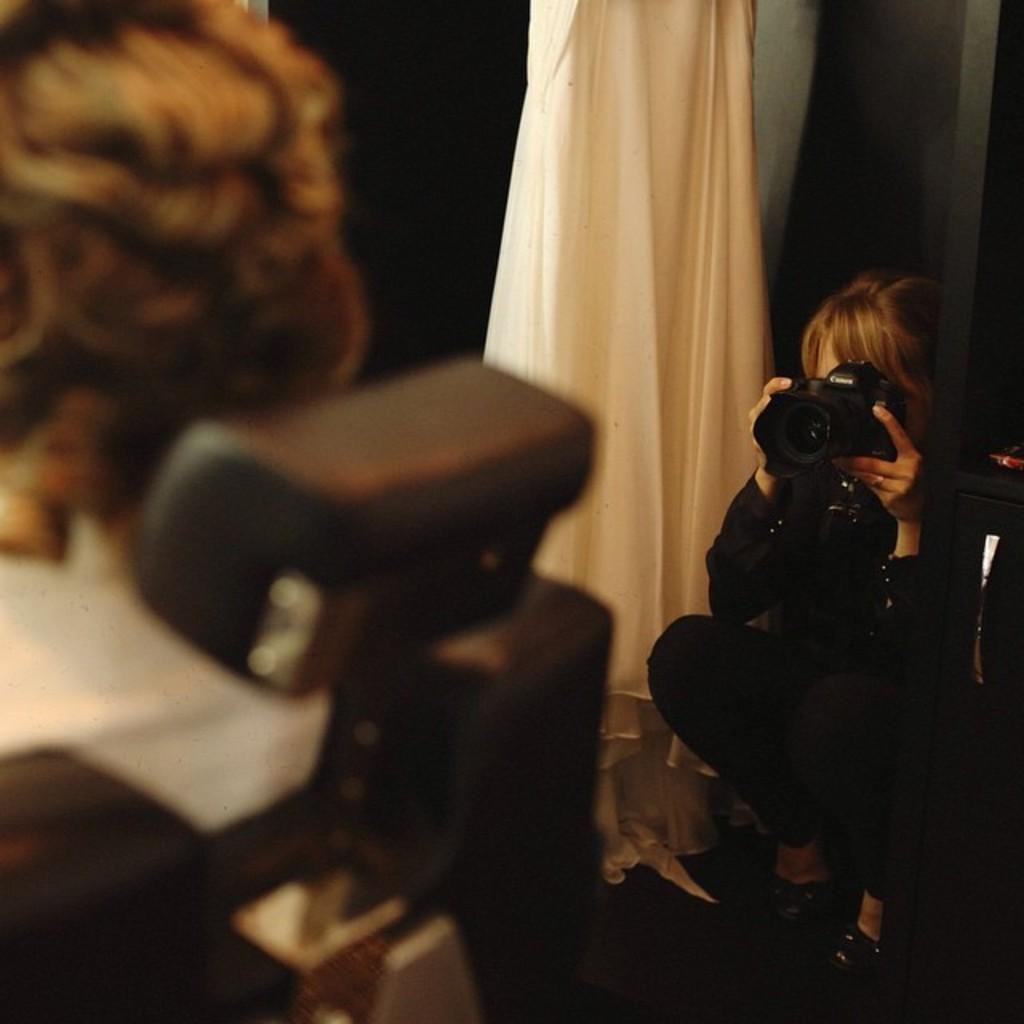Who is the main subject in the image? There is a woman in the image. What is the woman doing in the image? The woman is sitting in the image. What is the woman holding in her hand? The woman is holding a camera in her hand. Can you describe the person sitting in front of the woman? There is a person sitting in front of the woman, but their appearance cannot be clearly discerned due to the image being blurry. What type of cakes are being served for dinner in the image? There is no mention of cakes or dinner in the image; it features a woman sitting with a camera in her hand and another person sitting in front of her. 